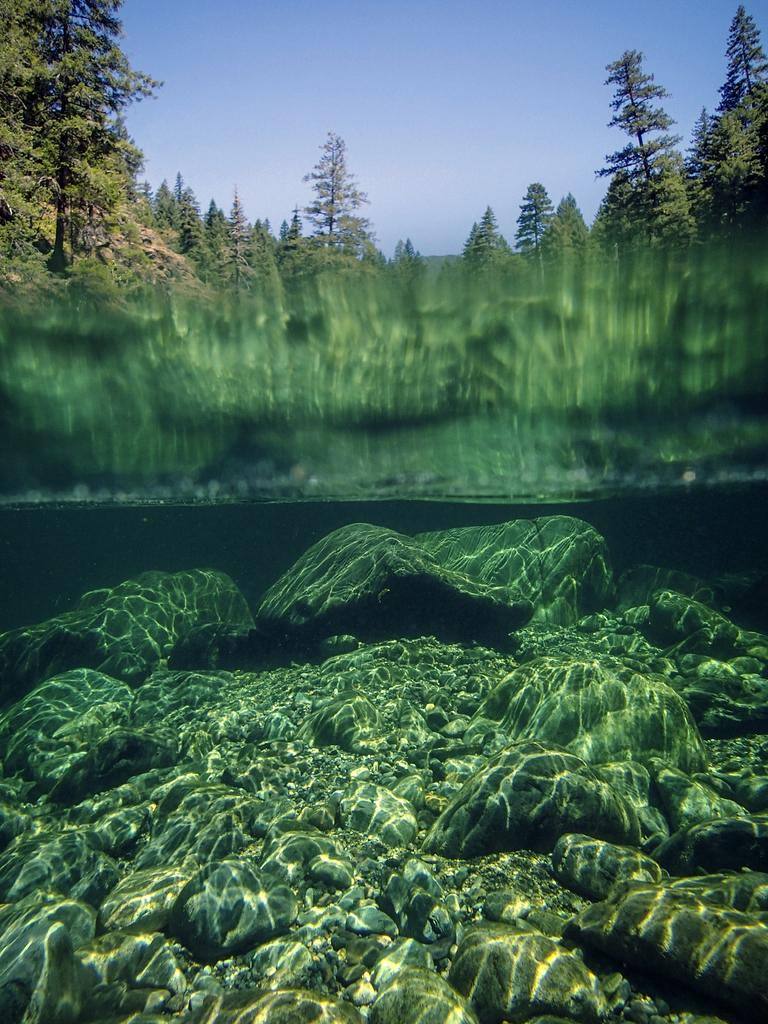What type of terrain is depicted in the image? There are rocks on the ground in the image, suggesting a rocky terrain. What is the primary setting of the image? The image appears to depict an inside view of a sea. What type of vegetation can be seen in the image? There are trees visible in the image. What part of the natural environment is visible in the image? The sky is visible in the image. What type of yam is being used as bait in the image? There is no yam or bait present in the image; it depicts an inside view of a sea with rocks and trees. 